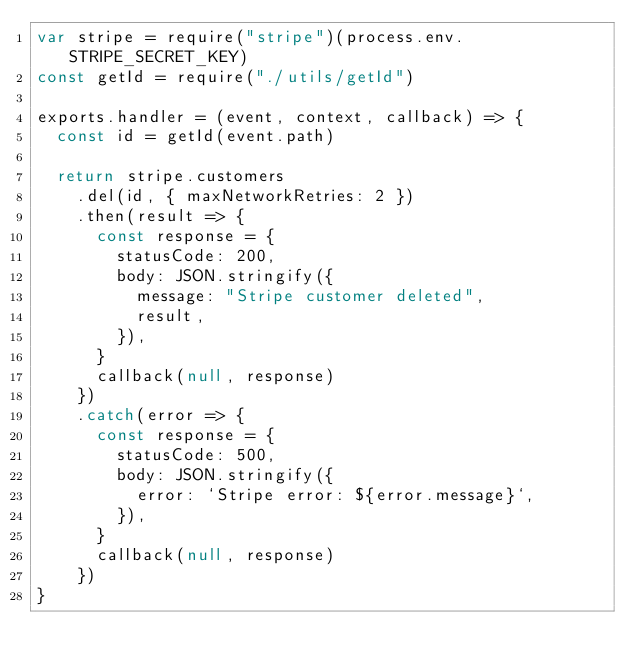Convert code to text. <code><loc_0><loc_0><loc_500><loc_500><_JavaScript_>var stripe = require("stripe")(process.env.STRIPE_SECRET_KEY)
const getId = require("./utils/getId")

exports.handler = (event, context, callback) => {
  const id = getId(event.path)

  return stripe.customers
    .del(id, { maxNetworkRetries: 2 })
    .then(result => {
      const response = {
        statusCode: 200,
        body: JSON.stringify({
          message: "Stripe customer deleted",
          result,
        }),
      }
      callback(null, response)
    })
    .catch(error => {
      const response = {
        statusCode: 500,
        body: JSON.stringify({
          error: `Stripe error: ${error.message}`,
        }),
      }
      callback(null, response)
    })
}
</code> 